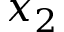<formula> <loc_0><loc_0><loc_500><loc_500>x _ { 2 }</formula> 